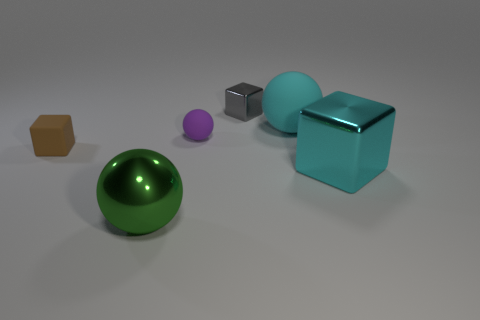Are there any other things that are the same material as the small gray cube?
Make the answer very short. Yes. Is there a block made of the same material as the gray object?
Offer a terse response. Yes. What is the color of the object that is both left of the small purple rubber ball and to the right of the tiny brown rubber cube?
Provide a short and direct response. Green. How many other objects are the same color as the tiny matte sphere?
Offer a terse response. 0. There is a tiny block right of the large sphere that is to the left of the gray block behind the small purple rubber ball; what is its material?
Ensure brevity in your answer.  Metal. How many cylinders are tiny purple things or cyan things?
Provide a short and direct response. 0. Are there any other things that have the same size as the gray shiny block?
Provide a succinct answer. Yes. There is a tiny matte thing right of the small cube to the left of the large green ball; what number of green things are left of it?
Your answer should be very brief. 1. Is the shape of the big cyan metallic thing the same as the large matte thing?
Your answer should be compact. No. Is the ball that is in front of the large cyan metallic cube made of the same material as the big ball behind the large green shiny sphere?
Give a very brief answer. No. 